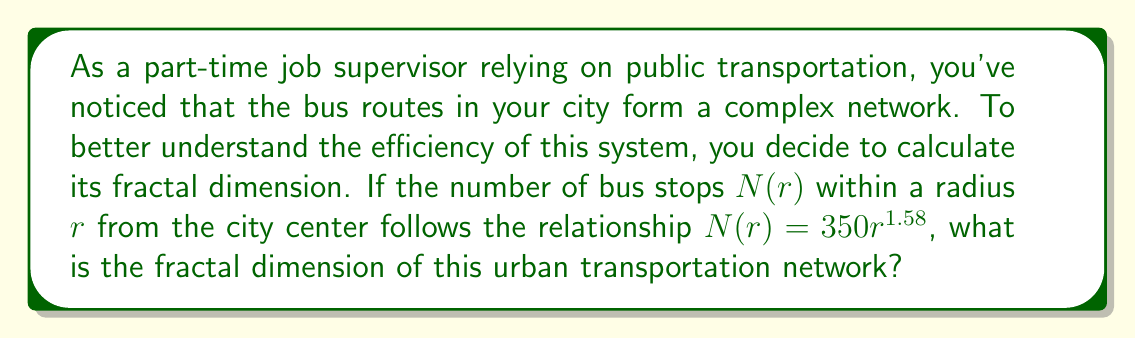Can you solve this math problem? To solve this problem, we'll follow these steps:

1. Recall the definition of fractal dimension:
   The fractal dimension $D$ is given by the relationship:
   
   $$N(r) = kr^D$$

   where $k$ is a constant, $r$ is the scale (radius in this case), and $N(r)$ is the number of objects (bus stops) at that scale.

2. Compare the given equation to the fractal dimension formula:
   
   Given: $N(r) = 350r^{1.58}$
   
   Here, $k = 350$ and the exponent $1.58$ represents the fractal dimension $D$.

3. Identify the fractal dimension:
   
   The fractal dimension $D$ is the exponent in the power-law relationship between $N(r)$ and $r$. In this case, $D = 1.58$.

4. Interpret the result:
   
   A fractal dimension of 1.58 indicates that the bus network is more complex than a simple line (dimension 1) but less space-filling than a plane (dimension 2). This suggests a moderately efficient coverage of the urban area by the transportation network.
Answer: $D = 1.58$ 